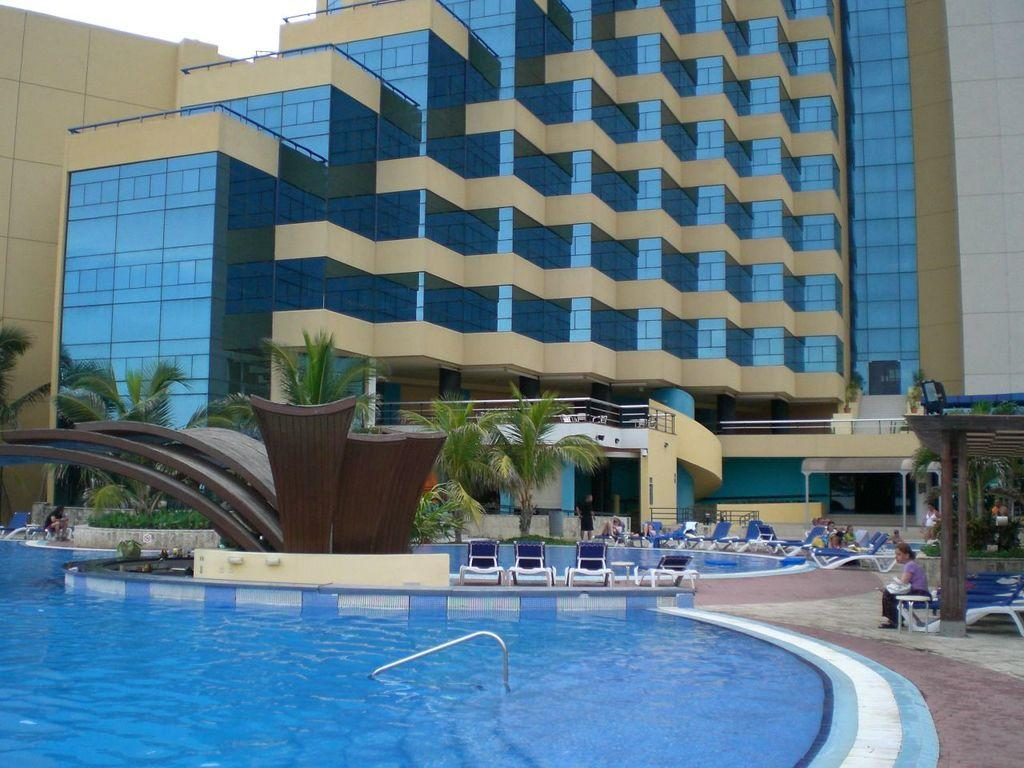What is the main feature in the image? There is a swimming pool in the image. What can be seen near the swimming pool? There are chairs in the image, and people are sitting on them. What is visible in the background of the image? There are trees and a glass building in the background of the image. What type of branch can be seen hanging from the glass building in the image? There is no branch hanging from the glass building in the image. What kind of jewel is being used as a decoration on the chairs in the image? There are no jewels present on the chairs in the image. 